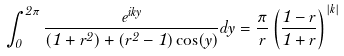Convert formula to latex. <formula><loc_0><loc_0><loc_500><loc_500>\int _ { 0 } ^ { 2 \pi } \frac { e ^ { i k y } } { ( 1 + r ^ { 2 } ) + ( r ^ { 2 } - 1 ) \cos ( y ) } d y = \frac { \pi } { r } \left ( \frac { 1 - r } { 1 + r } \right ) ^ { | k | }</formula> 